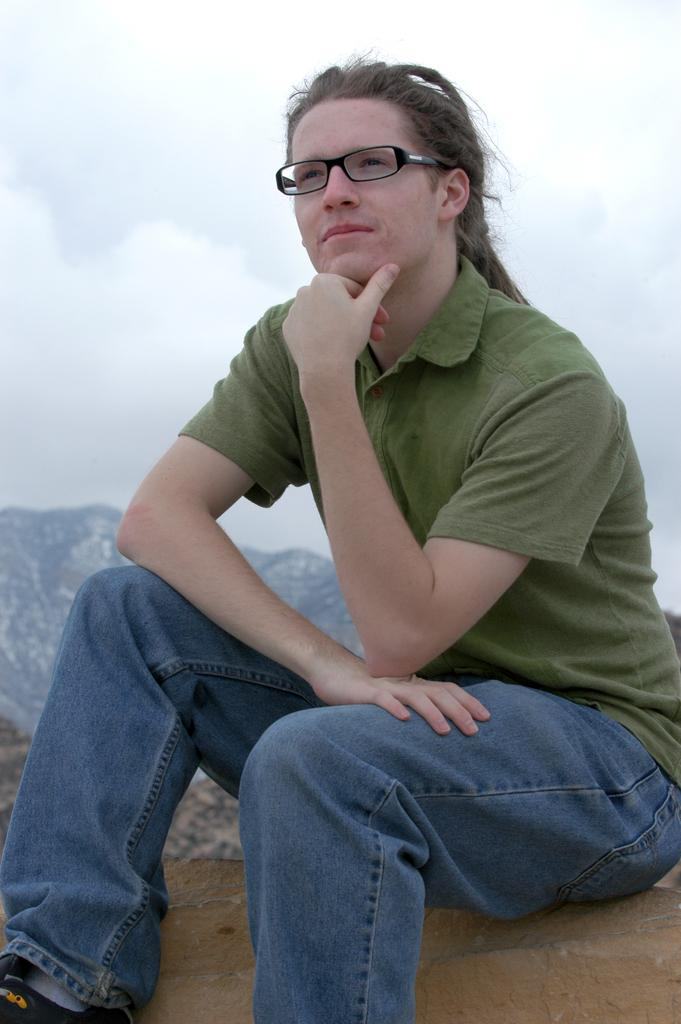What is the main subject of the image? There is a person in the image. What can be observed about the person's appearance? The person is wearing spectacles. What is the person doing in the image? The person is sitting. What type of natural landscape can be seen in the image? Mountains are visible in the image. What is visible in the background of the image? The sky is visible in the background of the image. What can be observed about the sky in the image? Clouds are present in the sky. Can you tell me how many rabbits are hopping in the field in the image? There is no field or rabbits present in the image; it features a person sitting with mountains and clouds visible in the background. 